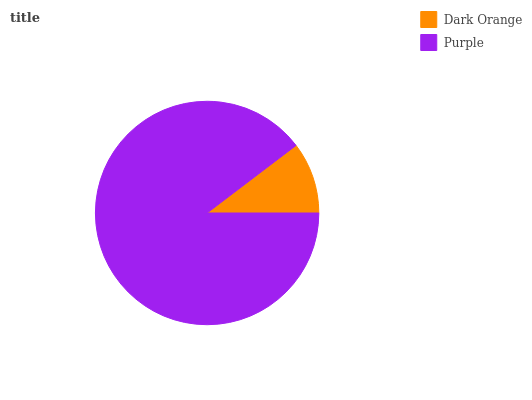Is Dark Orange the minimum?
Answer yes or no. Yes. Is Purple the maximum?
Answer yes or no. Yes. Is Purple the minimum?
Answer yes or no. No. Is Purple greater than Dark Orange?
Answer yes or no. Yes. Is Dark Orange less than Purple?
Answer yes or no. Yes. Is Dark Orange greater than Purple?
Answer yes or no. No. Is Purple less than Dark Orange?
Answer yes or no. No. Is Purple the high median?
Answer yes or no. Yes. Is Dark Orange the low median?
Answer yes or no. Yes. Is Dark Orange the high median?
Answer yes or no. No. Is Purple the low median?
Answer yes or no. No. 